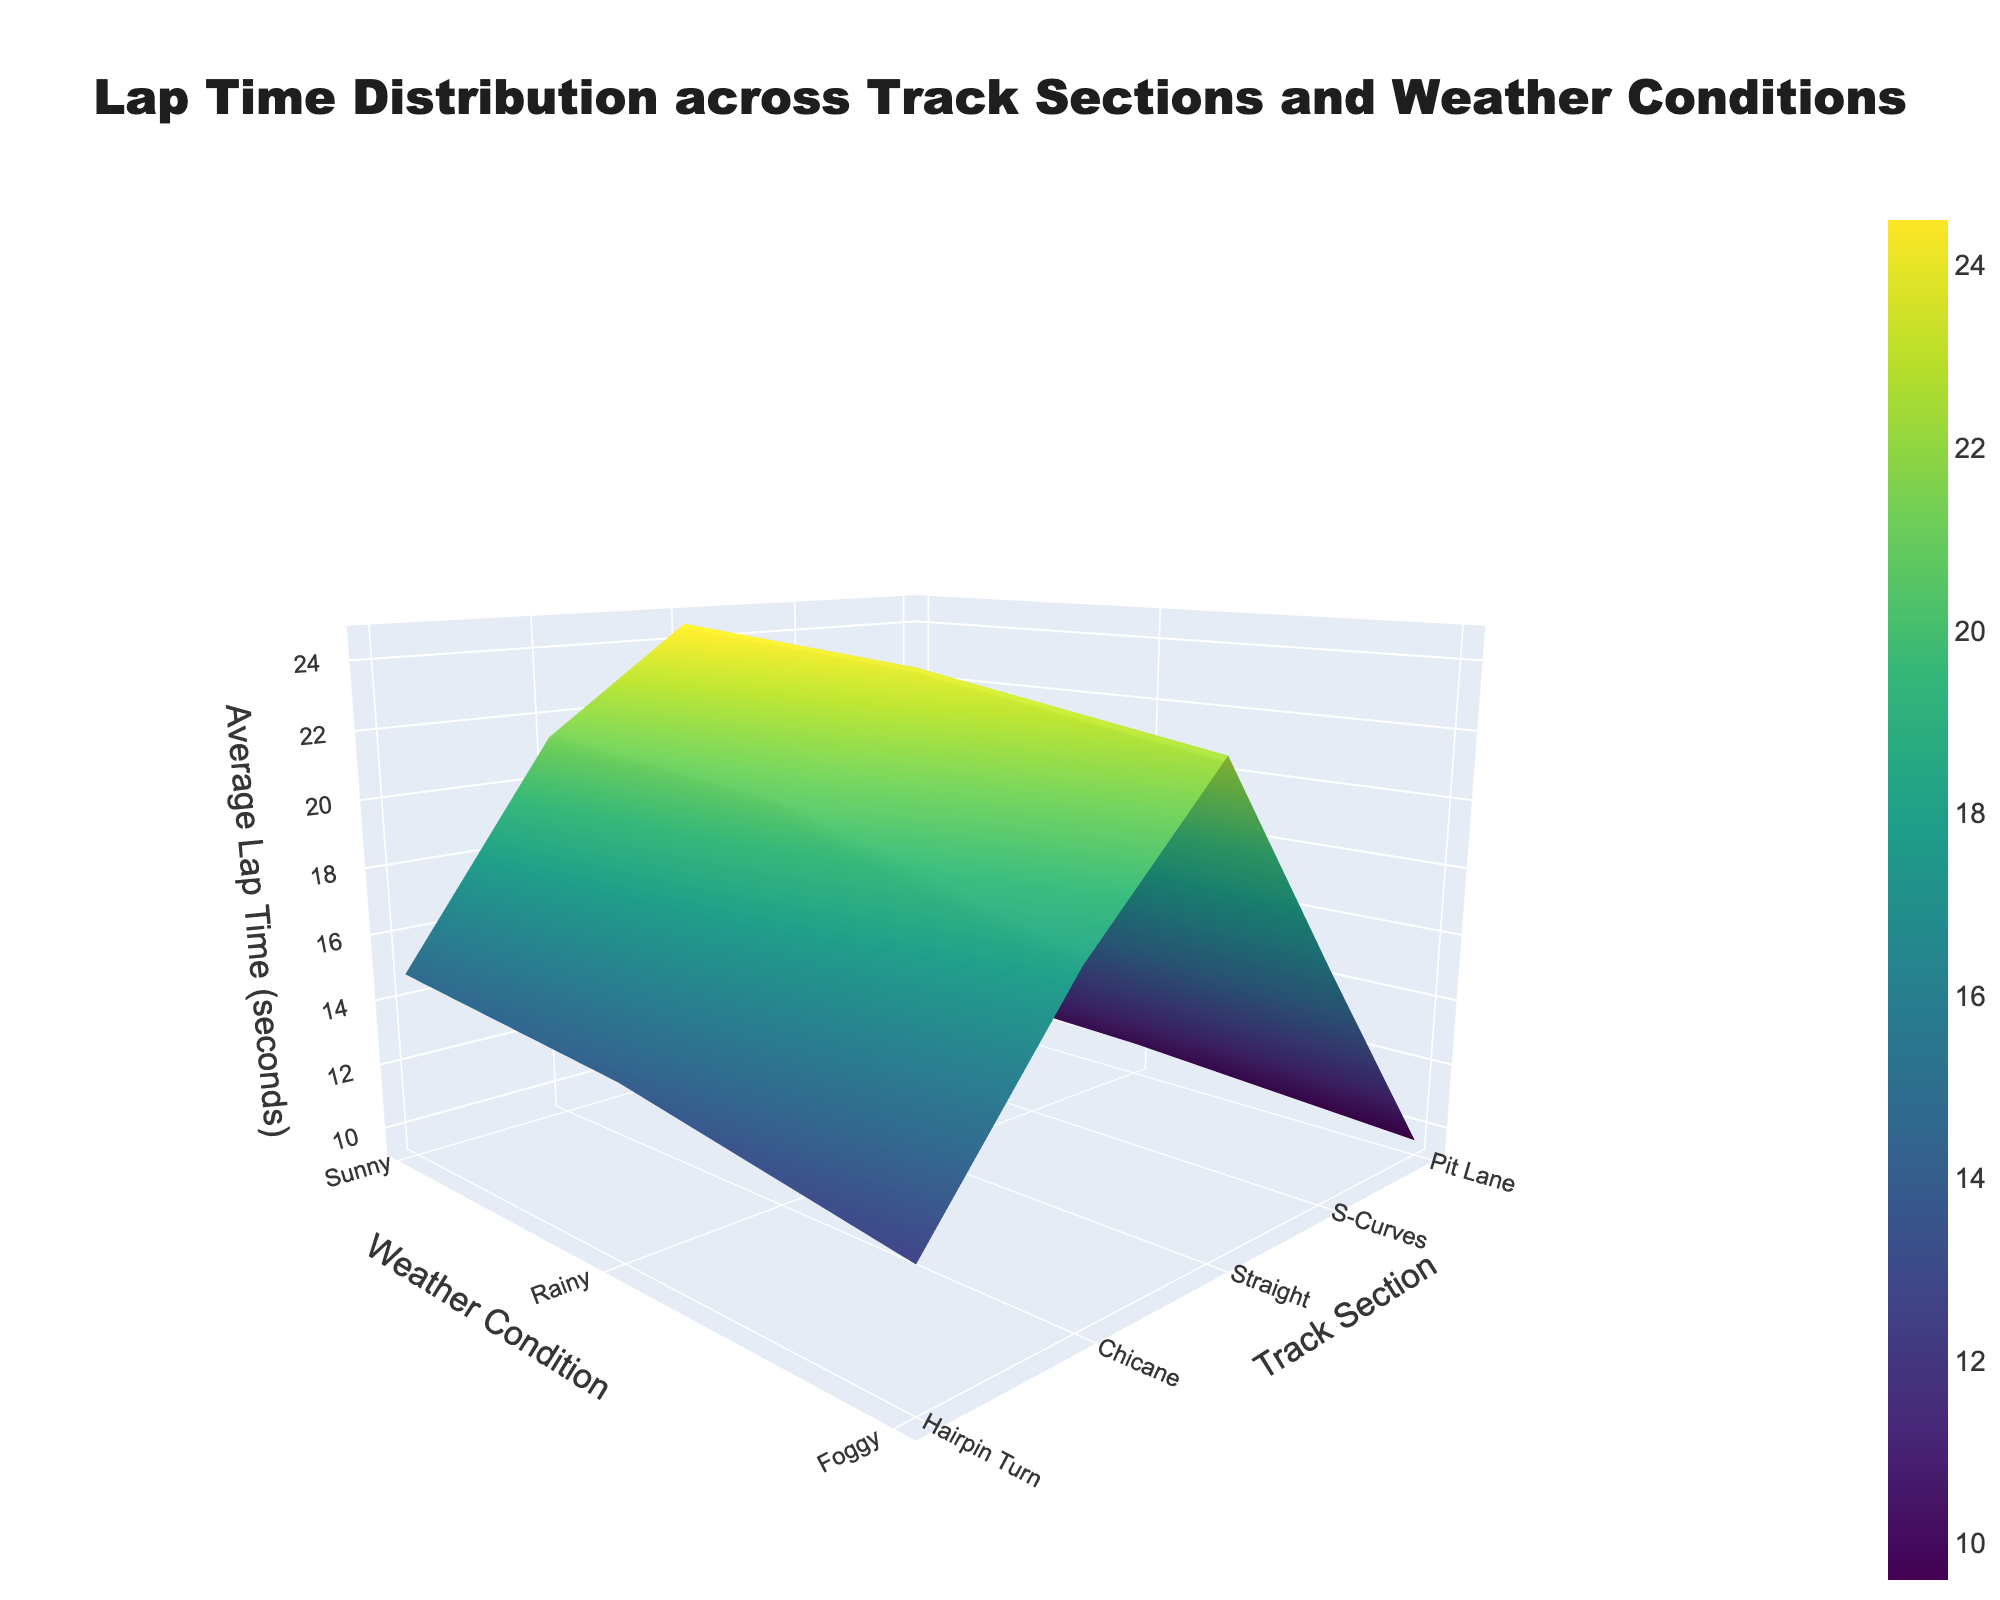What is the title of the 3D surface plot? The title is shown at the very top of the plot. It reads: "Lap Time Distribution across Track Sections and Weather Conditions".
Answer: Lap Time Distribution across Track Sections and Weather Conditions How does the average lap time vary between Sunny and Rainy conditions for the S-Curves section? Looking at the plot, you observe the height of the surface (z-axis) for the "S-Curves" track section under both "Sunny" and "Rainy" weather conditions. The height is lower for Sunny compared to Rainy conditions, indicating a shorter lap time.
Answer: Shorter lap time in Sunny Which track section has the highest average lap time overall? By observing the highest point on the z-axis across all track sections and weather conditions, you can determine that "Pit Lane" in "Foggy" conditions has the highest average lap time.
Answer: Pit Lane in Foggy conditions What is the difference in average lap time between the Hairpin Turn in Sunny and Foggy conditions? Check the height of the surface (z-axis) for "Hairpin Turn" under "Sunny" and "Foggy" conditions. The average lap time for Sunny is 18.2 seconds and for Foggy is 21.3 seconds. The difference is 21.3 - 18.2 = 3.1 seconds.
Answer: 3.1 seconds Which weather condition generally results in the slowest average lap times across most track sections? By examining the surface heights across the plot, you notice that "Foggy" conditions consistently lead to higher average lap times for most track sections.
Answer: Foggy What is the average lap time for the Straight section in Rainy conditions? Locate the "Straight" track section along the y-axis and find the corresponding height for "Rainy" conditions on the x-axis. The lap time is represented by the z-axis, which is 10.2 seconds.
Answer: 10.2 seconds Between Chicane and S-Curves, which section experiences a larger increase in average lap time from Sunny to Rainy conditions? For Chicane, the increase is from 12.7 to 14.1 seconds, which is 14.1 - 12.7 = 1.4 seconds. For S-Curves, the increase is from 15.9 to 17.6 seconds, which is 17.6 - 15.9 = 1.7 seconds. Compare these increases to see that S-Curves has a larger increase.
Answer: S-Curves What are the z-axis units representing in the 3D surface plot? The z-axis title states that it represents "Average Lap Time (seconds)".
Answer: Average Lap Time (seconds) Which track section shows the smallest variability in lap times across different weather conditions? By looking at the plot and examining the z-axis heights for each track section across various weather conditions, you can see that the "Straight" section has the smallest range in heights, indicating the least variability in lap times.
Answer: Straight 